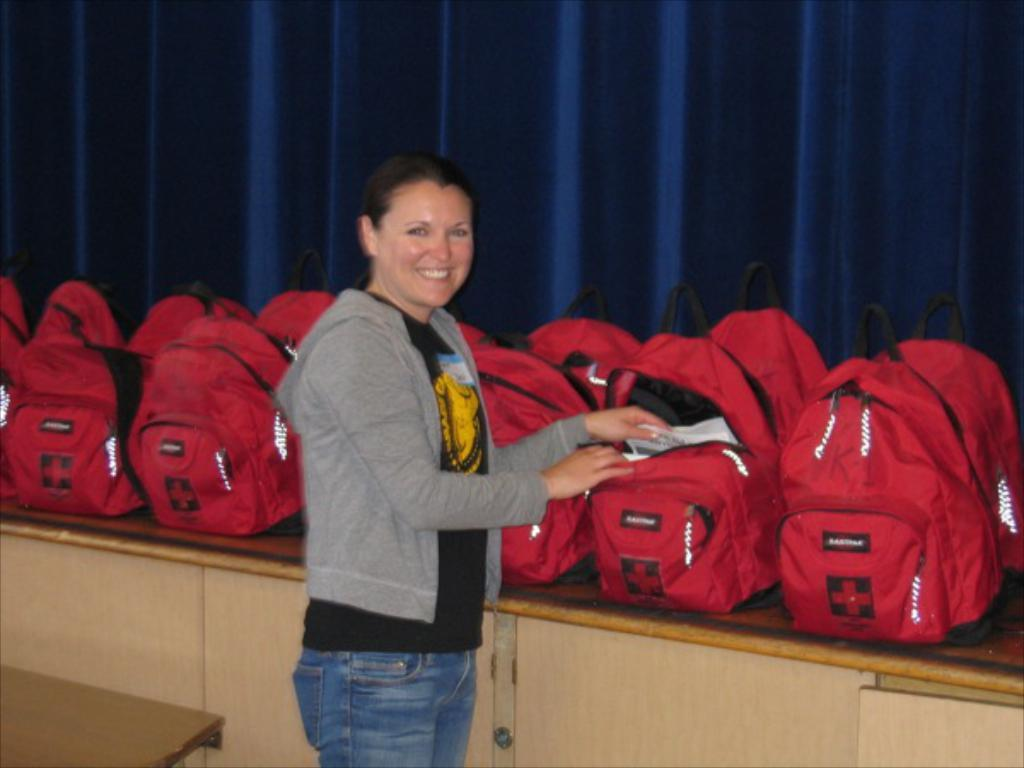Who is the main subject in the image? There is a woman in the image. Where is the woman positioned in the image? The woman is standing at the center. What is the woman's facial expression in the image? The woman is smiling. What is the woman trying to do in the image? The woman is trying to pick up something from the bag and open it. What can be seen in the background of the image? There are multiple bags in the background of the image. What type of fruit is the woman trying to bite in the image? There is no fruit present in the image, and the woman is not trying to bite anything. 